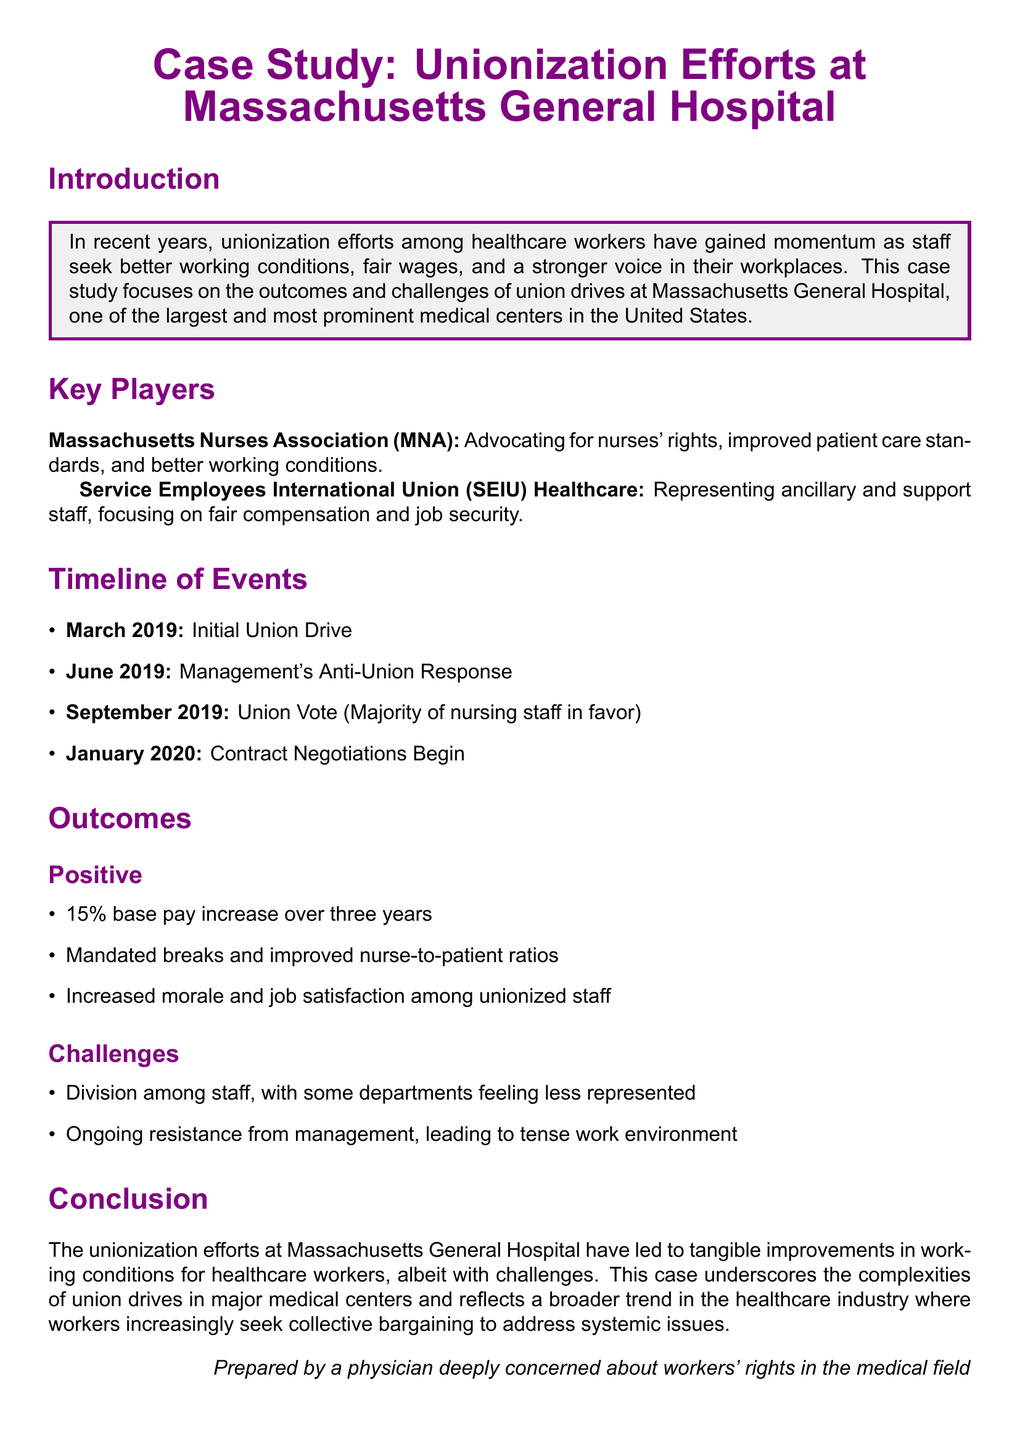What is the name of the hospital in the case study? The document specifies that the case study focuses on Massachusetts General Hospital.
Answer: Massachusetts General Hospital Which union advocates for nurses' rights? The document states that the Massachusetts Nurses Association advocates for nurses' rights.
Answer: Massachusetts Nurses Association When did the initial union drive begin? According to the timeline, the initial union drive started in March 2019.
Answer: March 2019 What percentage pay increase was achieved over three years? The outcomes section mentions a 15% base pay increase over three years.
Answer: 15% What was one challenge experienced during the unionization efforts? The document lists ongoing resistance from management as a challenge faced during unionization efforts.
Answer: Ongoing resistance from management What improvement was mandated regarding nurse-to-patient ratios? The outcomes section highlights that there were mandated breaks and improved nurse-to-patient ratios.
Answer: Improved nurse-to-patient ratios What organization represents ancillary and support staff? The document identifies the Service Employees International Union as representing ancillary and support staff.
Answer: Service Employees International Union In what month did the union vote take place? The timeline indicates that the union vote occurred in September 2019.
Answer: September 2019 